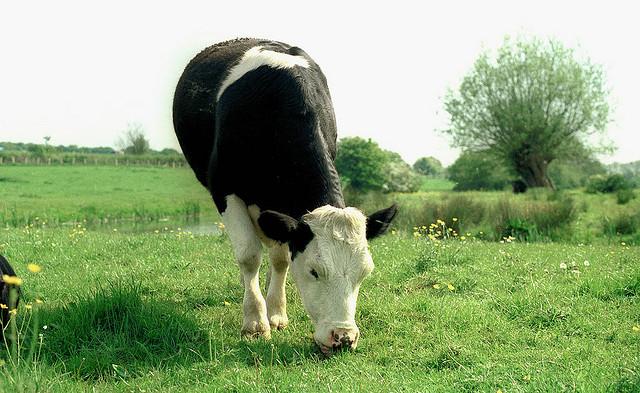Is the cow eating grass?
Short answer required. Yes. Does the grass need to be mowed?
Give a very brief answer. No. What is the name of this cow?
Be succinct. Bessy. 